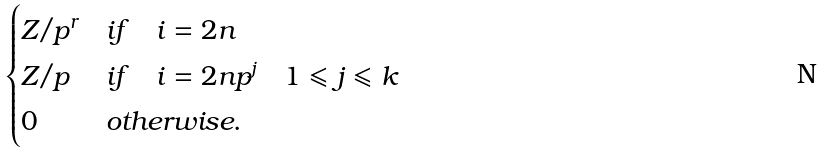Convert formula to latex. <formula><loc_0><loc_0><loc_500><loc_500>\begin{cases} Z / p ^ { r } & i f \quad i = 2 n \\ Z / p & i f \quad i = 2 n p ^ { j } \quad 1 \leqslant j \leqslant k \\ 0 & o t h e r w i s e . \end{cases}</formula> 